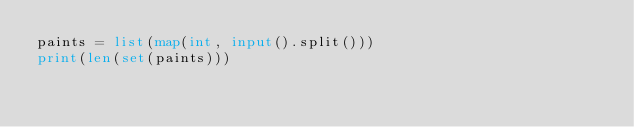Convert code to text. <code><loc_0><loc_0><loc_500><loc_500><_Python_>paints = list(map(int, input().split()))
print(len(set(paints)))
</code> 